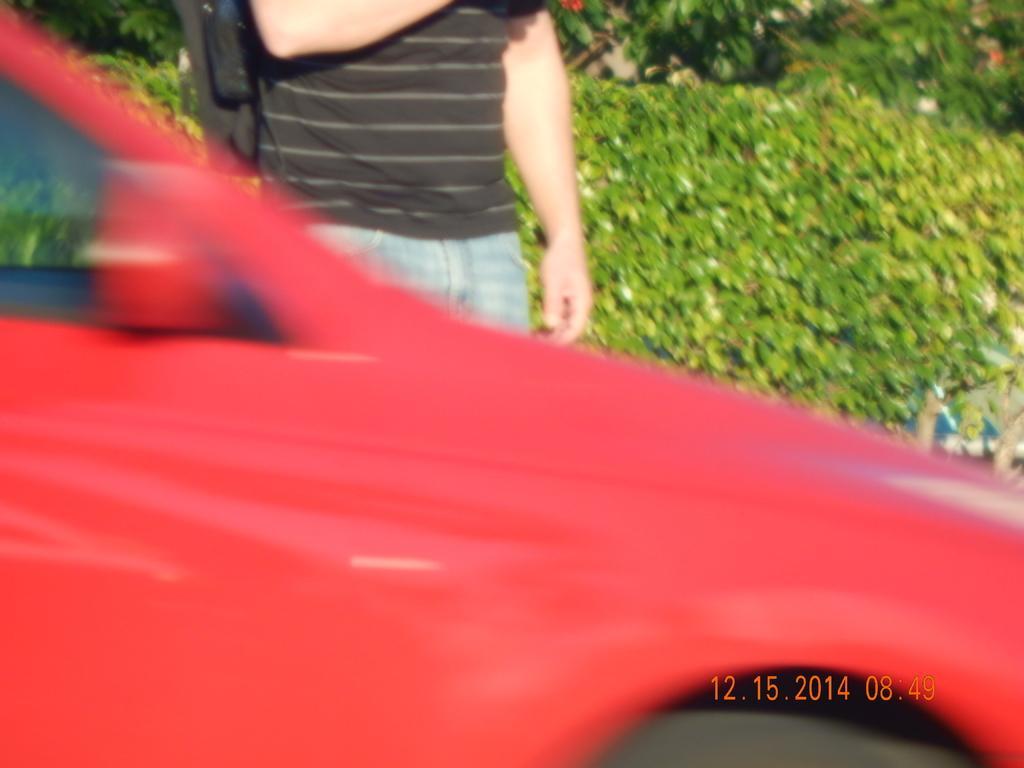In one or two sentences, can you explain what this image depicts? In this picture we can observe a person standing. There is a red color car. We can observe watermark on the right side. In the background there are plants. 